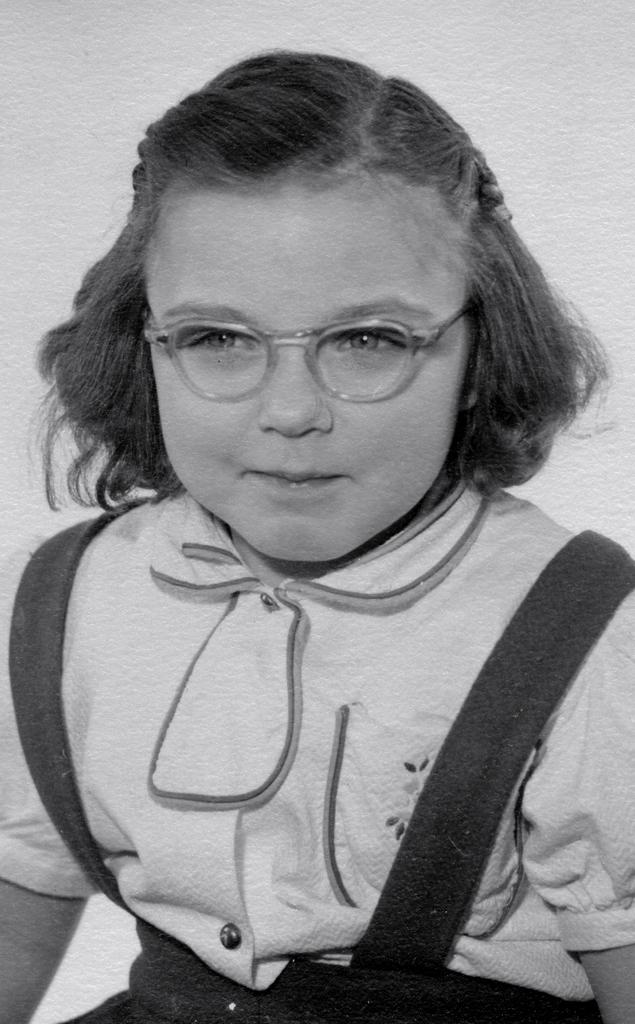Who is the main subject in the image? There is a girl in the image. What is the girl wearing in the image? The girl is wearing spectacles in the image. What is the color of the background in the image? The background of the image is white. What is the color scheme of the image? The image is black and white. What type of horn can be seen in the girl's hand in the image? There is no horn present in the image; the girl is not holding anything in her hand. What is the girl eating for lunch in the image? There is no lunch depicted in the image; it is a black and white photograph of a girl wearing spectacles against a white background. 